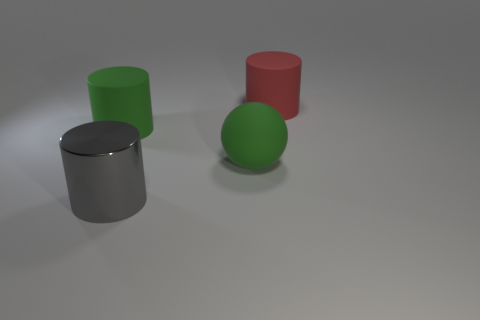Add 3 big red things. How many objects exist? 7 Subtract all red cylinders. How many cylinders are left? 2 Subtract 0 cyan spheres. How many objects are left? 4 Subtract all spheres. How many objects are left? 3 Subtract 1 cylinders. How many cylinders are left? 2 Subtract all gray cylinders. Subtract all gray spheres. How many cylinders are left? 2 Subtract all blue balls. How many gray cylinders are left? 1 Subtract all gray rubber cubes. Subtract all big gray shiny cylinders. How many objects are left? 3 Add 1 cylinders. How many cylinders are left? 4 Add 4 big cylinders. How many big cylinders exist? 7 